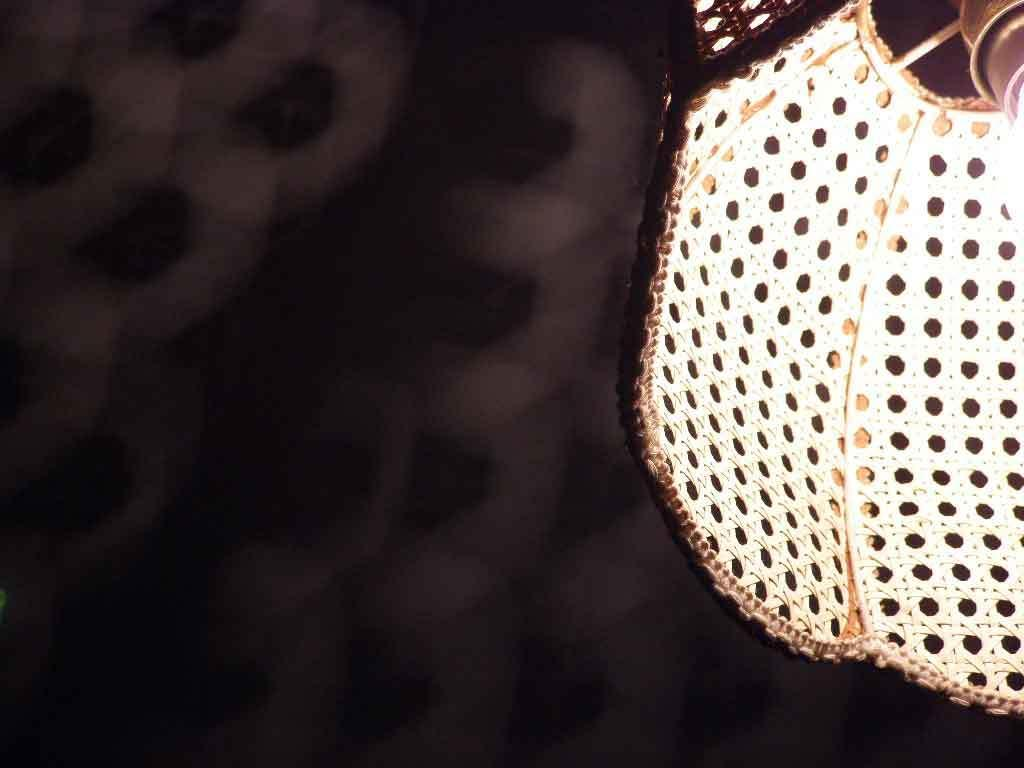What is the main subject in the image? There is an object in the image. Can you describe the background of the image? The background of the image is blurry. How many cups are visible in the image? There is no cup present in the image. What direction does the yard face in the image? There is no yard present in the image. 